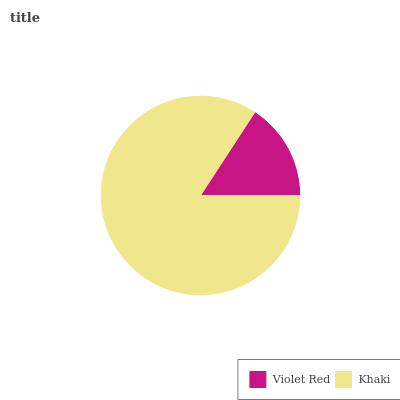Is Violet Red the minimum?
Answer yes or no. Yes. Is Khaki the maximum?
Answer yes or no. Yes. Is Khaki the minimum?
Answer yes or no. No. Is Khaki greater than Violet Red?
Answer yes or no. Yes. Is Violet Red less than Khaki?
Answer yes or no. Yes. Is Violet Red greater than Khaki?
Answer yes or no. No. Is Khaki less than Violet Red?
Answer yes or no. No. Is Khaki the high median?
Answer yes or no. Yes. Is Violet Red the low median?
Answer yes or no. Yes. Is Violet Red the high median?
Answer yes or no. No. Is Khaki the low median?
Answer yes or no. No. 